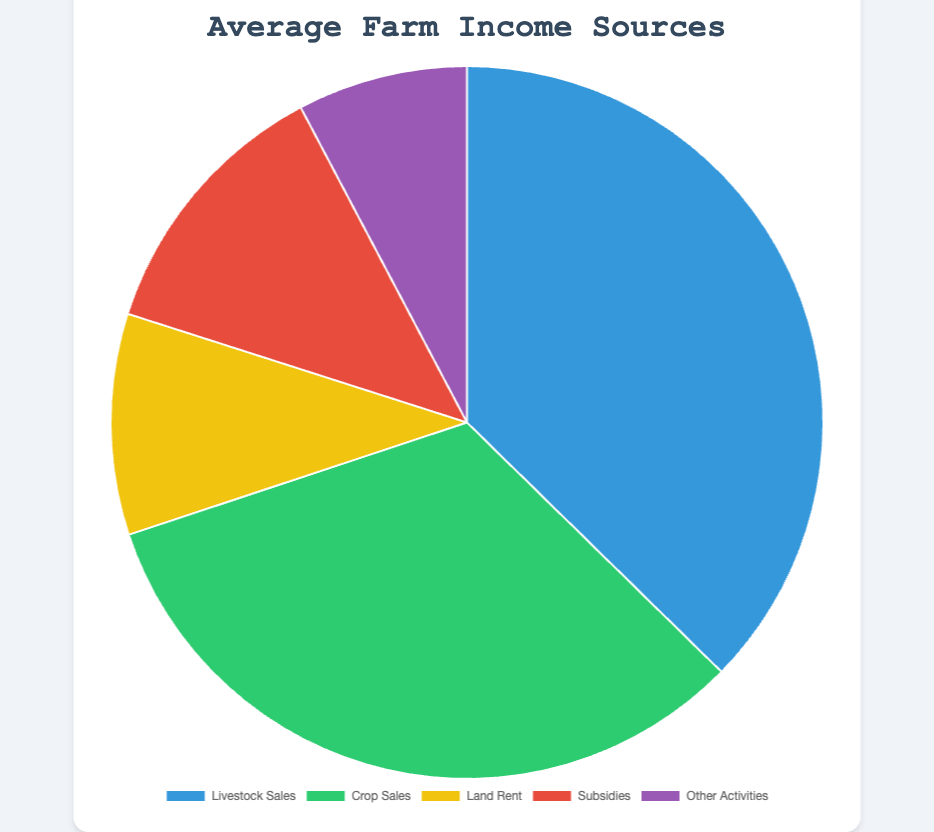Which income source accounts for the largest share in the pie chart? The income source that has the largest slice in the pie chart represents the largest share. By visual inspection, the "Livestock Sales" section appears to be the largest.
Answer: Livestock Sales How does 'Crop Sales' compare to 'Subsidies' in terms of percentage? To compare 'Crop Sales' to 'Subsidies', observe the sizes of their respective segments. 'Crop Sales' occupies a noticeably larger portion compared to 'Subsidies,' indicating it has a higher percentage.
Answer: Crop Sales has a higher percentage What is the total average income from 'Livestock Sales' and 'Crop Sales' combined? First, note the average values for 'Livestock Sales' and 'Crop Sales' from the chart. Sum these values to get the total. Livestock Sales: $45400, Crop Sales: $39600. Total: $45400 + $39600 = $85000.
Answer: $85000 Is the share of 'Other Activities' greater than 'Rent Land'? Compare the slices for 'Other Activities' and 'Rent Land'. 'Other Activities' has a visibly larger slice than 'Rent Land', indicating a greater share.
Answer: Yes What's the approximate percentage of 'Subsidies' in the total average income sources? Each segment's percentage can be approximated by comparing its size to the full circle. 'Subsidies' has a smaller segment than 'Livestock Sales' and 'Crop Sales', appearing to be about 15-20% of the pie chart.
Answer: Approximately 15-20% If you remove 'Subsidies' and 'Rent Land', what proportion of the remaining income comes from 'Crop Sales'? First, exclude 'Subsidies' and 'Rent Land' from the total. Then, compare the 'Crop Sales' slice to the new total. Crop Sales is roughly half of the combined remaining major sections (Livestock Sales, Crop Sales, Other Activities).
Answer: About 50% Which is smaller, 'Rent Land' or 'Other Activities'? Assess the size of the slices. 'Rent Land' appears smaller than 'Other Activities', indicating it is smaller.
Answer: Rent Land 